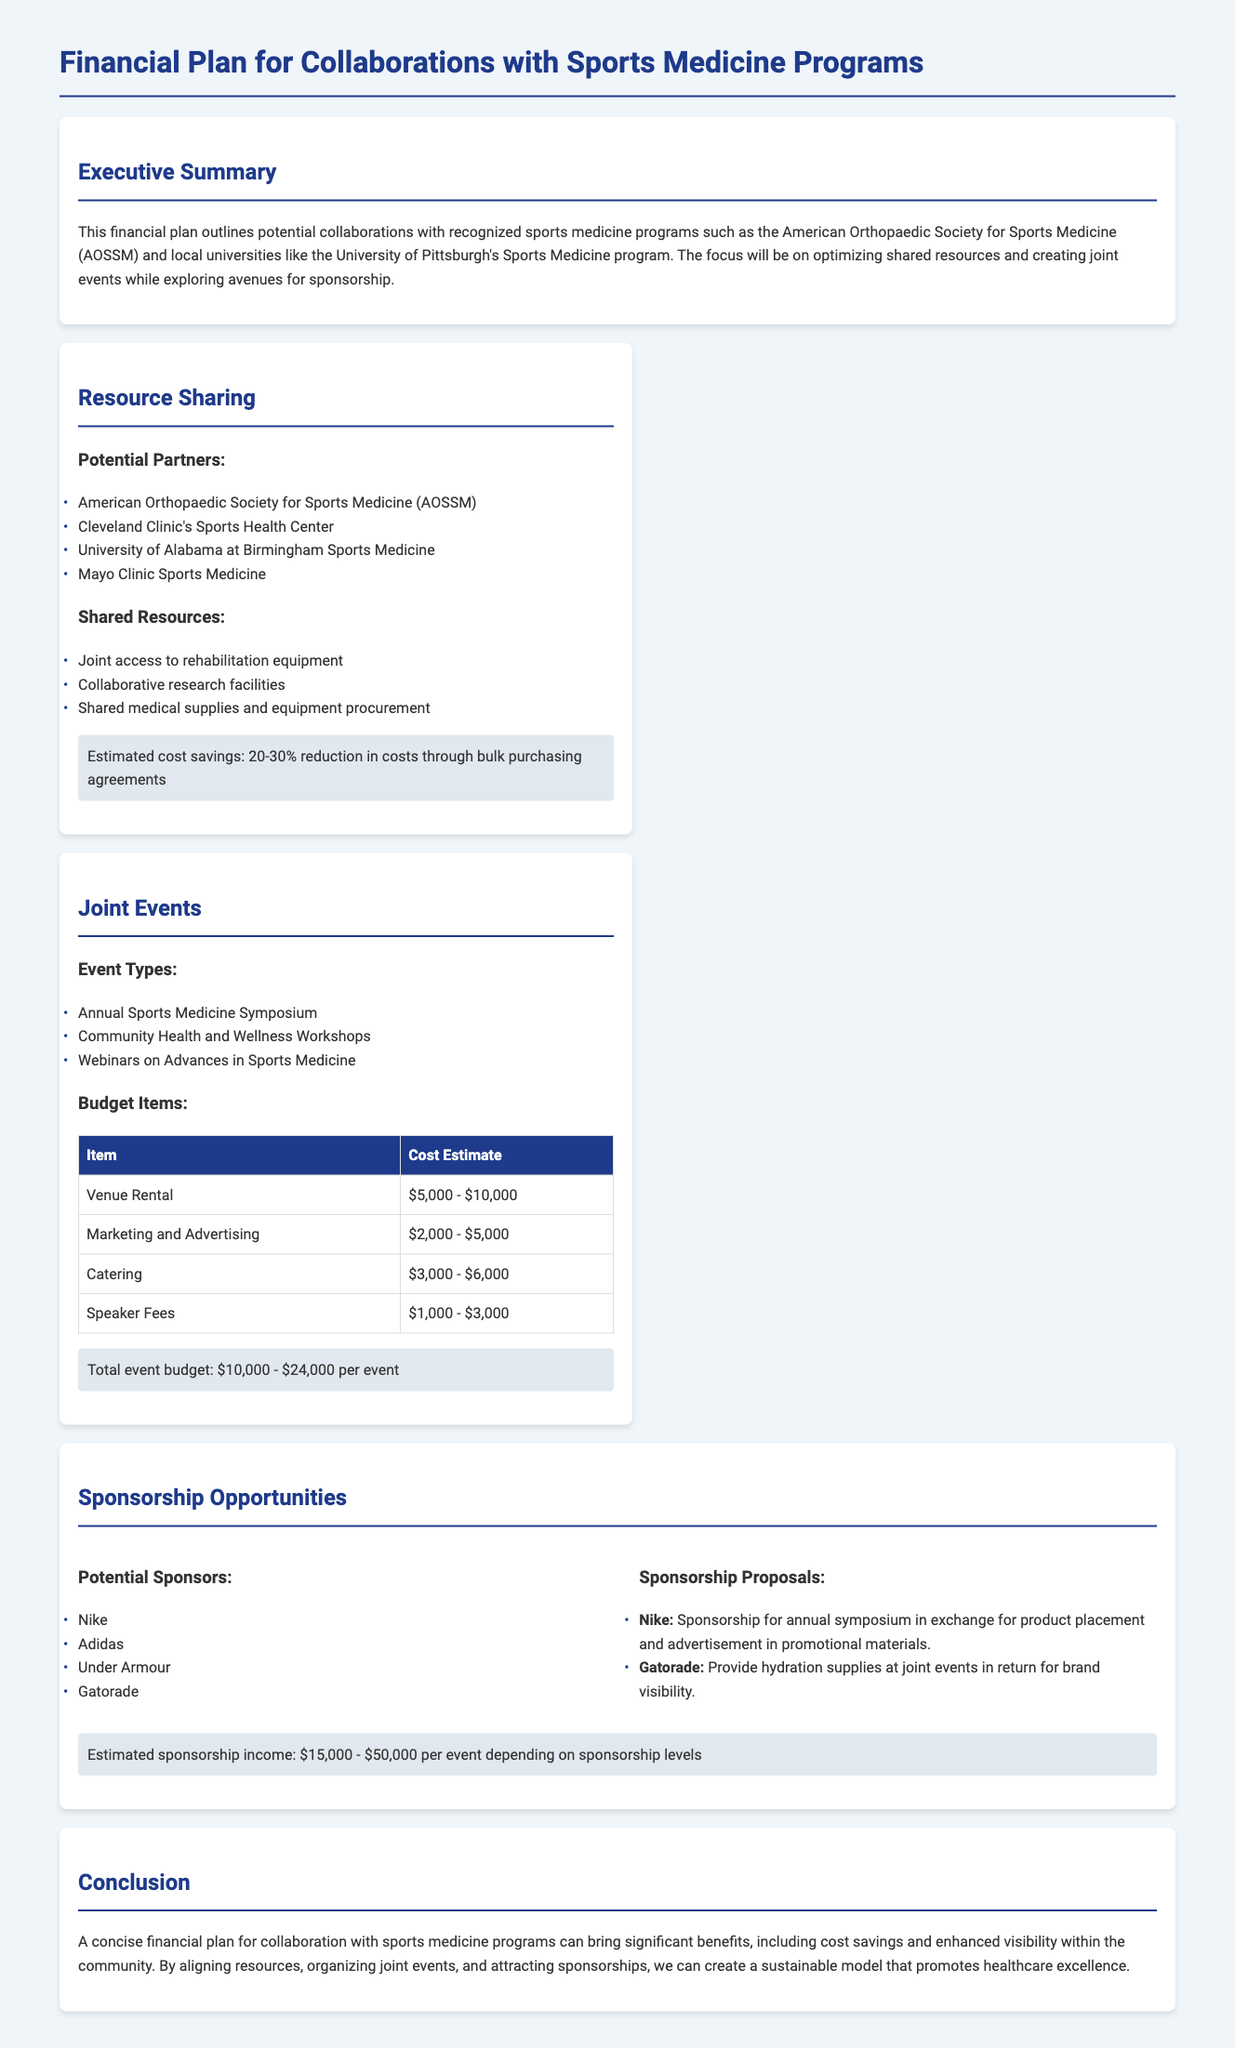What are the estimated cost savings from shared resources? The document states that estimated cost savings are a 20-30% reduction in costs through bulk purchasing agreements.
Answer: 20-30% What is the total estimated budget for joint events? The total event budget is outlined as $10,000 - $24,000 per event.
Answer: $10,000 - $24,000 Who are the potential sponsors listed in the document? The document lists potential sponsors, including Nike, Adidas, Under Armour, and Gatorade.
Answer: Nike, Adidas, Under Armour, Gatorade What is the cost estimate range for venue rental? The document provides a cost estimate range for venue rental as $5,000 - $10,000.
Answer: $5,000 - $10,000 What is a proposed sponsorship opportunity for Nike? The document mentions that Nike's proposal includes sponsorship for the annual symposium in exchange for product placement and advertisement in promotional materials.
Answer: Sponsorship for annual symposium What types of events are planned according to the document? The planned events are the Annual Sports Medicine Symposium, Community Health and Wellness Workshops, and Webinars on Advances in Sports Medicine.
Answer: Annual Sports Medicine Symposium, Community Health and Wellness Workshops, Webinars What is the estimated income from sponsorships per event? The document states the estimated sponsorship income as $15,000 - $50,000 per event, depending on sponsorship levels.
Answer: $15,000 - $50,000 What are the shared resources mentioned? Shared resources include joint access to rehabilitation equipment, collaborative research facilities, and shared medical supplies and equipment procurement.
Answer: Joint access to rehabilitation equipment, collaborative research facilities, shared medical supplies and equipment procurement What are the marketing costs estimated for events? The cost estimate for marketing and advertising is listed as $2,000 - $5,000 in the document.
Answer: $2,000 - $5,000 